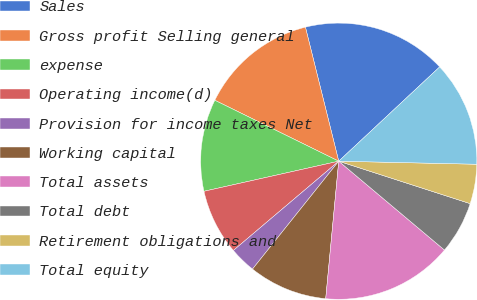<chart> <loc_0><loc_0><loc_500><loc_500><pie_chart><fcel>Sales<fcel>Gross profit Selling general<fcel>expense<fcel>Operating income(d)<fcel>Provision for income taxes Net<fcel>Working capital<fcel>Total assets<fcel>Total debt<fcel>Retirement obligations and<fcel>Total equity<nl><fcel>16.92%<fcel>13.85%<fcel>10.77%<fcel>7.69%<fcel>3.08%<fcel>9.23%<fcel>15.38%<fcel>6.15%<fcel>4.62%<fcel>12.31%<nl></chart> 